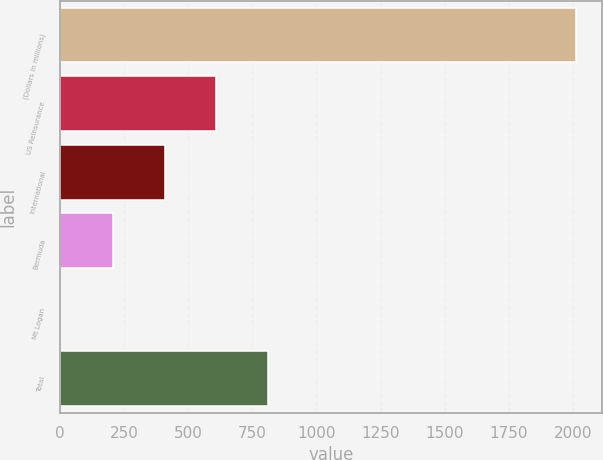Convert chart. <chart><loc_0><loc_0><loc_500><loc_500><bar_chart><fcel>(Dollars in millions)<fcel>US Reinsurance<fcel>International<fcel>Bermuda<fcel>Mt Logan<fcel>Total<nl><fcel>2013<fcel>610.34<fcel>409.07<fcel>207.8<fcel>0.3<fcel>811.61<nl></chart> 